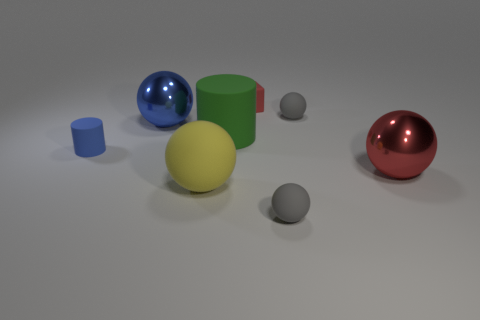There is a large rubber cylinder; is its color the same as the metallic ball behind the red shiny ball?
Ensure brevity in your answer.  No. How many other things are the same color as the large matte cylinder?
Offer a terse response. 0. There is a matte ball that is behind the large green object; is it the same size as the green object in front of the small cube?
Offer a very short reply. No. There is a big sphere to the right of the yellow rubber object; what is its color?
Offer a terse response. Red. Is the number of tiny objects behind the big red sphere less than the number of small green cylinders?
Provide a short and direct response. No. Is the material of the big yellow ball the same as the blue cylinder?
Keep it short and to the point. Yes. There is a blue object that is the same shape as the large red thing; what size is it?
Provide a short and direct response. Large. How many things are gray matte balls that are behind the red sphere or things that are behind the yellow object?
Your answer should be compact. 6. Are there fewer small green rubber cylinders than blue metal spheres?
Your answer should be compact. Yes. Does the red metallic sphere have the same size as the matte cylinder on the left side of the green cylinder?
Offer a terse response. No. 